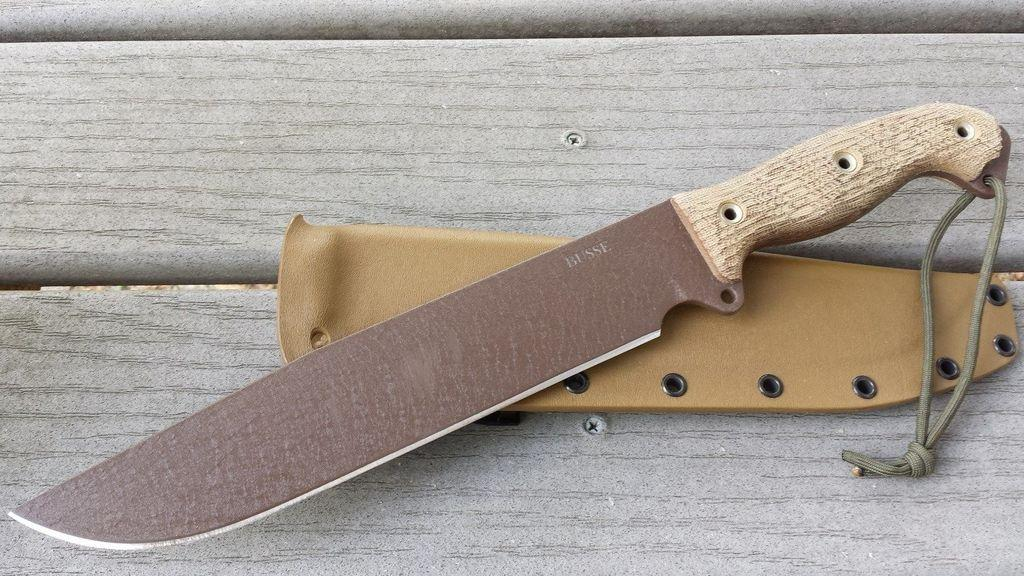What object is present in the image that is typically used for cutting? There is a knife in the image. How is the knife being protected or stored in the image? The knife is on a knife cover. What type of surface is the knife cover placed on in the image? The knife cover is on a wooden surface. What direction is the screw turning in the image? There is no screw present in the image. 